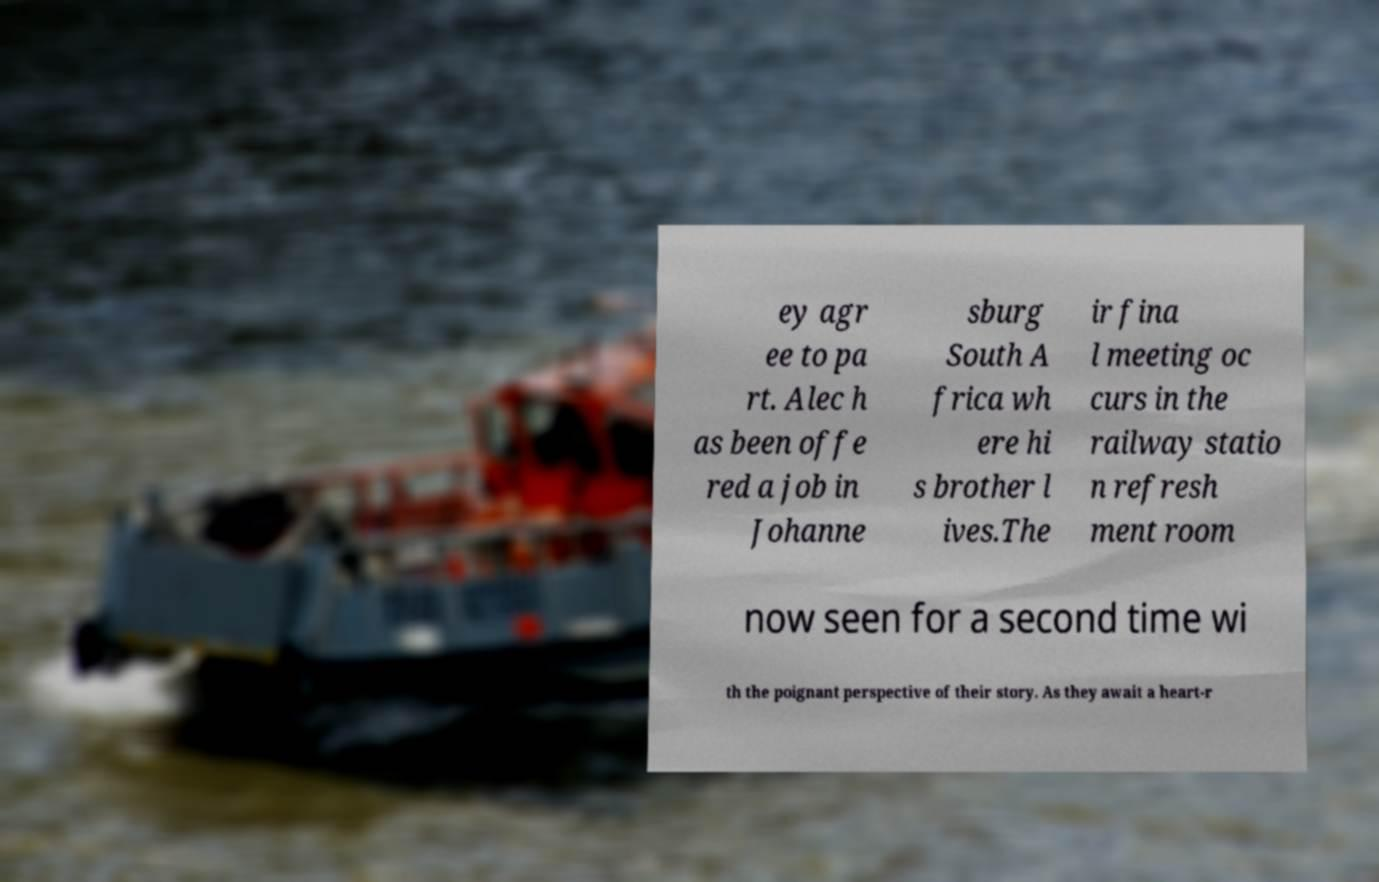Could you assist in decoding the text presented in this image and type it out clearly? ey agr ee to pa rt. Alec h as been offe red a job in Johanne sburg South A frica wh ere hi s brother l ives.The ir fina l meeting oc curs in the railway statio n refresh ment room now seen for a second time wi th the poignant perspective of their story. As they await a heart-r 